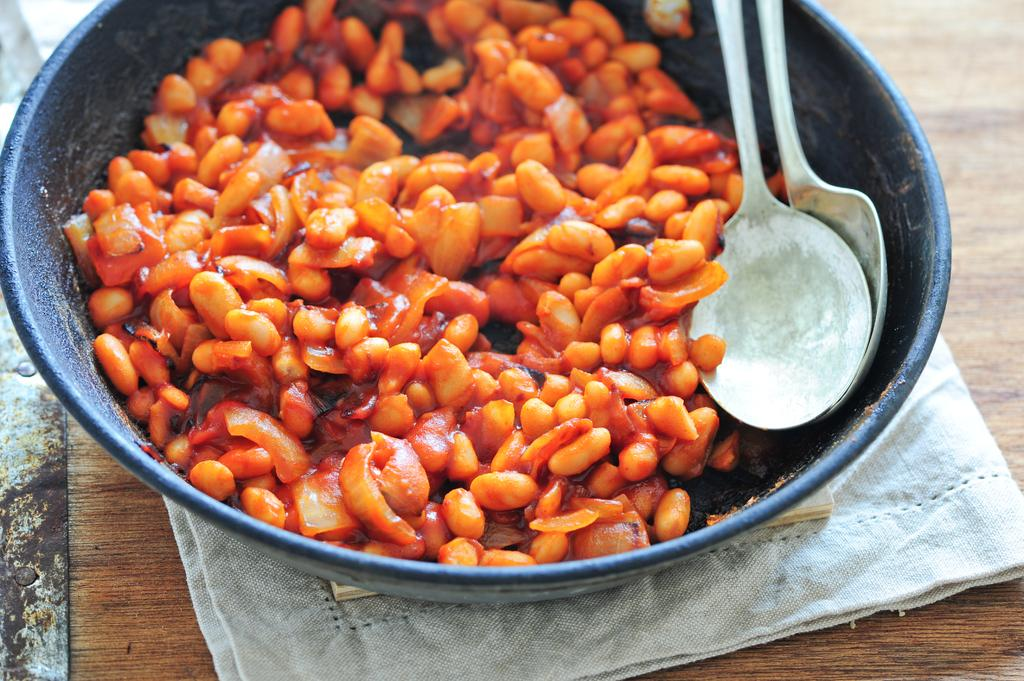What type of surface is visible in the image? The image contains a wooden surface. What is placed on the wooden surface? There is a cloth on the wooden surface. What is on top of the cloth? There is a black bowl on the cloth. What is inside the black bowl? The bowl contains beans. How many spoons are in the bowl? There are two spoons in the bowl. How many babies are crawling on the wooden surface in the image? There are no babies present in the image; it only shows a wooden surface, a cloth, a black bowl, beans, and two spoons. 